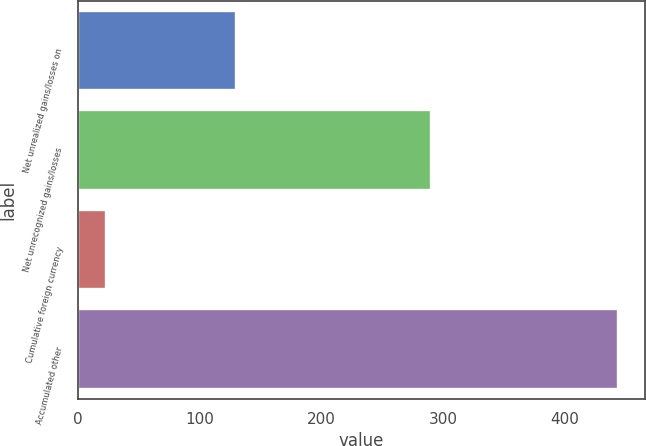<chart> <loc_0><loc_0><loc_500><loc_500><bar_chart><fcel>Net unrealized gains/losses on<fcel>Net unrecognized gains/losses<fcel>Cumulative foreign currency<fcel>Accumulated other<nl><fcel>130<fcel>290<fcel>23<fcel>443<nl></chart> 